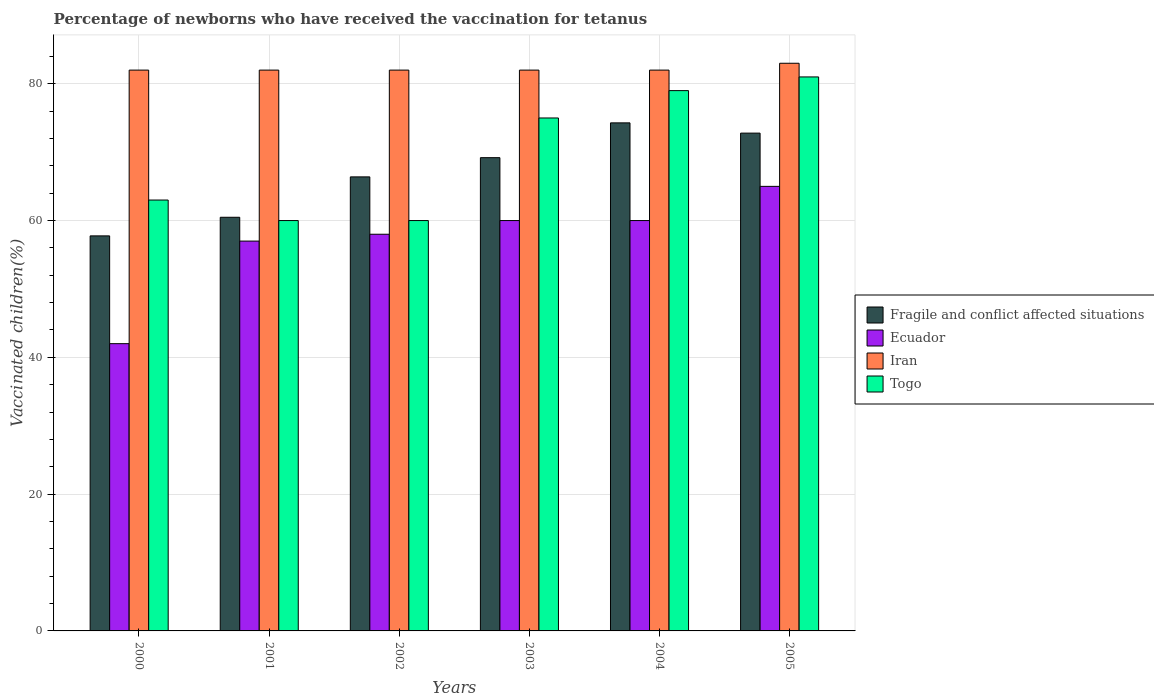How many groups of bars are there?
Provide a succinct answer. 6. Are the number of bars on each tick of the X-axis equal?
Your answer should be compact. Yes. How many bars are there on the 2nd tick from the right?
Ensure brevity in your answer.  4. In how many cases, is the number of bars for a given year not equal to the number of legend labels?
Offer a very short reply. 0. What is the percentage of vaccinated children in Fragile and conflict affected situations in 2004?
Make the answer very short. 74.28. Across all years, what is the maximum percentage of vaccinated children in Ecuador?
Ensure brevity in your answer.  65. In which year was the percentage of vaccinated children in Fragile and conflict affected situations maximum?
Ensure brevity in your answer.  2004. In which year was the percentage of vaccinated children in Iran minimum?
Your response must be concise. 2000. What is the total percentage of vaccinated children in Ecuador in the graph?
Offer a terse response. 342. What is the difference between the percentage of vaccinated children in Fragile and conflict affected situations in 2001 and that in 2005?
Your response must be concise. -12.3. What is the difference between the percentage of vaccinated children in Ecuador in 2000 and the percentage of vaccinated children in Iran in 2001?
Ensure brevity in your answer.  -40. What is the average percentage of vaccinated children in Iran per year?
Provide a short and direct response. 82.17. In the year 2001, what is the difference between the percentage of vaccinated children in Fragile and conflict affected situations and percentage of vaccinated children in Ecuador?
Provide a succinct answer. 3.48. What is the ratio of the percentage of vaccinated children in Fragile and conflict affected situations in 2002 to that in 2004?
Provide a short and direct response. 0.89. Is the percentage of vaccinated children in Iran in 2001 less than that in 2003?
Ensure brevity in your answer.  No. What is the difference between the highest and the second highest percentage of vaccinated children in Ecuador?
Your response must be concise. 5. What is the difference between the highest and the lowest percentage of vaccinated children in Togo?
Provide a succinct answer. 21. In how many years, is the percentage of vaccinated children in Togo greater than the average percentage of vaccinated children in Togo taken over all years?
Provide a succinct answer. 3. What does the 3rd bar from the left in 2003 represents?
Offer a terse response. Iran. What does the 2nd bar from the right in 2005 represents?
Offer a terse response. Iran. How many years are there in the graph?
Your response must be concise. 6. What is the difference between two consecutive major ticks on the Y-axis?
Make the answer very short. 20. How many legend labels are there?
Provide a succinct answer. 4. How are the legend labels stacked?
Ensure brevity in your answer.  Vertical. What is the title of the graph?
Ensure brevity in your answer.  Percentage of newborns who have received the vaccination for tetanus. Does "Australia" appear as one of the legend labels in the graph?
Your answer should be very brief. No. What is the label or title of the X-axis?
Your response must be concise. Years. What is the label or title of the Y-axis?
Make the answer very short. Vaccinated children(%). What is the Vaccinated children(%) of Fragile and conflict affected situations in 2000?
Provide a succinct answer. 57.76. What is the Vaccinated children(%) of Ecuador in 2000?
Make the answer very short. 42. What is the Vaccinated children(%) of Togo in 2000?
Offer a terse response. 63. What is the Vaccinated children(%) of Fragile and conflict affected situations in 2001?
Ensure brevity in your answer.  60.48. What is the Vaccinated children(%) of Iran in 2001?
Your answer should be very brief. 82. What is the Vaccinated children(%) of Fragile and conflict affected situations in 2002?
Keep it short and to the point. 66.39. What is the Vaccinated children(%) in Ecuador in 2002?
Keep it short and to the point. 58. What is the Vaccinated children(%) in Iran in 2002?
Offer a very short reply. 82. What is the Vaccinated children(%) of Fragile and conflict affected situations in 2003?
Your answer should be very brief. 69.2. What is the Vaccinated children(%) in Fragile and conflict affected situations in 2004?
Keep it short and to the point. 74.28. What is the Vaccinated children(%) in Togo in 2004?
Give a very brief answer. 79. What is the Vaccinated children(%) of Fragile and conflict affected situations in 2005?
Keep it short and to the point. 72.78. What is the Vaccinated children(%) in Togo in 2005?
Keep it short and to the point. 81. Across all years, what is the maximum Vaccinated children(%) of Fragile and conflict affected situations?
Provide a short and direct response. 74.28. Across all years, what is the maximum Vaccinated children(%) in Iran?
Your response must be concise. 83. Across all years, what is the maximum Vaccinated children(%) of Togo?
Provide a succinct answer. 81. Across all years, what is the minimum Vaccinated children(%) of Fragile and conflict affected situations?
Your response must be concise. 57.76. Across all years, what is the minimum Vaccinated children(%) in Ecuador?
Provide a short and direct response. 42. Across all years, what is the minimum Vaccinated children(%) of Iran?
Your answer should be very brief. 82. What is the total Vaccinated children(%) in Fragile and conflict affected situations in the graph?
Offer a very short reply. 400.9. What is the total Vaccinated children(%) of Ecuador in the graph?
Keep it short and to the point. 342. What is the total Vaccinated children(%) in Iran in the graph?
Your response must be concise. 493. What is the total Vaccinated children(%) in Togo in the graph?
Your answer should be very brief. 418. What is the difference between the Vaccinated children(%) in Fragile and conflict affected situations in 2000 and that in 2001?
Offer a very short reply. -2.72. What is the difference between the Vaccinated children(%) of Iran in 2000 and that in 2001?
Give a very brief answer. 0. What is the difference between the Vaccinated children(%) in Fragile and conflict affected situations in 2000 and that in 2002?
Ensure brevity in your answer.  -8.63. What is the difference between the Vaccinated children(%) in Ecuador in 2000 and that in 2002?
Your response must be concise. -16. What is the difference between the Vaccinated children(%) in Iran in 2000 and that in 2002?
Your answer should be compact. 0. What is the difference between the Vaccinated children(%) of Togo in 2000 and that in 2002?
Provide a short and direct response. 3. What is the difference between the Vaccinated children(%) in Fragile and conflict affected situations in 2000 and that in 2003?
Offer a terse response. -11.44. What is the difference between the Vaccinated children(%) of Ecuador in 2000 and that in 2003?
Provide a succinct answer. -18. What is the difference between the Vaccinated children(%) of Iran in 2000 and that in 2003?
Offer a very short reply. 0. What is the difference between the Vaccinated children(%) in Fragile and conflict affected situations in 2000 and that in 2004?
Offer a very short reply. -16.52. What is the difference between the Vaccinated children(%) in Ecuador in 2000 and that in 2004?
Offer a very short reply. -18. What is the difference between the Vaccinated children(%) in Fragile and conflict affected situations in 2000 and that in 2005?
Your answer should be compact. -15.02. What is the difference between the Vaccinated children(%) in Iran in 2000 and that in 2005?
Give a very brief answer. -1. What is the difference between the Vaccinated children(%) in Fragile and conflict affected situations in 2001 and that in 2002?
Ensure brevity in your answer.  -5.91. What is the difference between the Vaccinated children(%) of Ecuador in 2001 and that in 2002?
Keep it short and to the point. -1. What is the difference between the Vaccinated children(%) of Iran in 2001 and that in 2002?
Give a very brief answer. 0. What is the difference between the Vaccinated children(%) in Fragile and conflict affected situations in 2001 and that in 2003?
Offer a very short reply. -8.71. What is the difference between the Vaccinated children(%) in Fragile and conflict affected situations in 2001 and that in 2004?
Make the answer very short. -13.8. What is the difference between the Vaccinated children(%) in Iran in 2001 and that in 2004?
Your response must be concise. 0. What is the difference between the Vaccinated children(%) in Fragile and conflict affected situations in 2001 and that in 2005?
Give a very brief answer. -12.3. What is the difference between the Vaccinated children(%) of Ecuador in 2001 and that in 2005?
Give a very brief answer. -8. What is the difference between the Vaccinated children(%) of Iran in 2001 and that in 2005?
Your answer should be compact. -1. What is the difference between the Vaccinated children(%) of Fragile and conflict affected situations in 2002 and that in 2003?
Your response must be concise. -2.81. What is the difference between the Vaccinated children(%) in Ecuador in 2002 and that in 2003?
Offer a terse response. -2. What is the difference between the Vaccinated children(%) in Iran in 2002 and that in 2003?
Keep it short and to the point. 0. What is the difference between the Vaccinated children(%) of Fragile and conflict affected situations in 2002 and that in 2004?
Your answer should be compact. -7.9. What is the difference between the Vaccinated children(%) of Ecuador in 2002 and that in 2004?
Your answer should be compact. -2. What is the difference between the Vaccinated children(%) of Fragile and conflict affected situations in 2002 and that in 2005?
Your response must be concise. -6.4. What is the difference between the Vaccinated children(%) of Ecuador in 2002 and that in 2005?
Ensure brevity in your answer.  -7. What is the difference between the Vaccinated children(%) of Iran in 2002 and that in 2005?
Your response must be concise. -1. What is the difference between the Vaccinated children(%) in Togo in 2002 and that in 2005?
Provide a succinct answer. -21. What is the difference between the Vaccinated children(%) of Fragile and conflict affected situations in 2003 and that in 2004?
Offer a very short reply. -5.09. What is the difference between the Vaccinated children(%) of Iran in 2003 and that in 2004?
Your answer should be very brief. 0. What is the difference between the Vaccinated children(%) in Fragile and conflict affected situations in 2003 and that in 2005?
Make the answer very short. -3.59. What is the difference between the Vaccinated children(%) of Ecuador in 2003 and that in 2005?
Your answer should be very brief. -5. What is the difference between the Vaccinated children(%) of Iran in 2003 and that in 2005?
Your response must be concise. -1. What is the difference between the Vaccinated children(%) of Fragile and conflict affected situations in 2004 and that in 2005?
Your response must be concise. 1.5. What is the difference between the Vaccinated children(%) in Ecuador in 2004 and that in 2005?
Keep it short and to the point. -5. What is the difference between the Vaccinated children(%) in Fragile and conflict affected situations in 2000 and the Vaccinated children(%) in Ecuador in 2001?
Ensure brevity in your answer.  0.76. What is the difference between the Vaccinated children(%) in Fragile and conflict affected situations in 2000 and the Vaccinated children(%) in Iran in 2001?
Offer a terse response. -24.24. What is the difference between the Vaccinated children(%) of Fragile and conflict affected situations in 2000 and the Vaccinated children(%) of Togo in 2001?
Your response must be concise. -2.24. What is the difference between the Vaccinated children(%) in Ecuador in 2000 and the Vaccinated children(%) in Iran in 2001?
Give a very brief answer. -40. What is the difference between the Vaccinated children(%) of Ecuador in 2000 and the Vaccinated children(%) of Togo in 2001?
Offer a terse response. -18. What is the difference between the Vaccinated children(%) in Fragile and conflict affected situations in 2000 and the Vaccinated children(%) in Ecuador in 2002?
Provide a succinct answer. -0.24. What is the difference between the Vaccinated children(%) in Fragile and conflict affected situations in 2000 and the Vaccinated children(%) in Iran in 2002?
Ensure brevity in your answer.  -24.24. What is the difference between the Vaccinated children(%) in Fragile and conflict affected situations in 2000 and the Vaccinated children(%) in Togo in 2002?
Make the answer very short. -2.24. What is the difference between the Vaccinated children(%) in Iran in 2000 and the Vaccinated children(%) in Togo in 2002?
Provide a short and direct response. 22. What is the difference between the Vaccinated children(%) of Fragile and conflict affected situations in 2000 and the Vaccinated children(%) of Ecuador in 2003?
Provide a succinct answer. -2.24. What is the difference between the Vaccinated children(%) in Fragile and conflict affected situations in 2000 and the Vaccinated children(%) in Iran in 2003?
Your response must be concise. -24.24. What is the difference between the Vaccinated children(%) in Fragile and conflict affected situations in 2000 and the Vaccinated children(%) in Togo in 2003?
Provide a succinct answer. -17.24. What is the difference between the Vaccinated children(%) of Ecuador in 2000 and the Vaccinated children(%) of Iran in 2003?
Keep it short and to the point. -40. What is the difference between the Vaccinated children(%) in Ecuador in 2000 and the Vaccinated children(%) in Togo in 2003?
Provide a short and direct response. -33. What is the difference between the Vaccinated children(%) of Fragile and conflict affected situations in 2000 and the Vaccinated children(%) of Ecuador in 2004?
Ensure brevity in your answer.  -2.24. What is the difference between the Vaccinated children(%) of Fragile and conflict affected situations in 2000 and the Vaccinated children(%) of Iran in 2004?
Give a very brief answer. -24.24. What is the difference between the Vaccinated children(%) of Fragile and conflict affected situations in 2000 and the Vaccinated children(%) of Togo in 2004?
Make the answer very short. -21.24. What is the difference between the Vaccinated children(%) in Ecuador in 2000 and the Vaccinated children(%) in Togo in 2004?
Provide a short and direct response. -37. What is the difference between the Vaccinated children(%) of Fragile and conflict affected situations in 2000 and the Vaccinated children(%) of Ecuador in 2005?
Ensure brevity in your answer.  -7.24. What is the difference between the Vaccinated children(%) of Fragile and conflict affected situations in 2000 and the Vaccinated children(%) of Iran in 2005?
Give a very brief answer. -25.24. What is the difference between the Vaccinated children(%) of Fragile and conflict affected situations in 2000 and the Vaccinated children(%) of Togo in 2005?
Your response must be concise. -23.24. What is the difference between the Vaccinated children(%) in Ecuador in 2000 and the Vaccinated children(%) in Iran in 2005?
Your answer should be very brief. -41. What is the difference between the Vaccinated children(%) of Ecuador in 2000 and the Vaccinated children(%) of Togo in 2005?
Make the answer very short. -39. What is the difference between the Vaccinated children(%) in Fragile and conflict affected situations in 2001 and the Vaccinated children(%) in Ecuador in 2002?
Give a very brief answer. 2.48. What is the difference between the Vaccinated children(%) of Fragile and conflict affected situations in 2001 and the Vaccinated children(%) of Iran in 2002?
Provide a short and direct response. -21.52. What is the difference between the Vaccinated children(%) of Fragile and conflict affected situations in 2001 and the Vaccinated children(%) of Togo in 2002?
Make the answer very short. 0.48. What is the difference between the Vaccinated children(%) in Fragile and conflict affected situations in 2001 and the Vaccinated children(%) in Ecuador in 2003?
Keep it short and to the point. 0.48. What is the difference between the Vaccinated children(%) of Fragile and conflict affected situations in 2001 and the Vaccinated children(%) of Iran in 2003?
Provide a short and direct response. -21.52. What is the difference between the Vaccinated children(%) in Fragile and conflict affected situations in 2001 and the Vaccinated children(%) in Togo in 2003?
Offer a very short reply. -14.52. What is the difference between the Vaccinated children(%) of Ecuador in 2001 and the Vaccinated children(%) of Iran in 2003?
Make the answer very short. -25. What is the difference between the Vaccinated children(%) in Ecuador in 2001 and the Vaccinated children(%) in Togo in 2003?
Make the answer very short. -18. What is the difference between the Vaccinated children(%) of Fragile and conflict affected situations in 2001 and the Vaccinated children(%) of Ecuador in 2004?
Keep it short and to the point. 0.48. What is the difference between the Vaccinated children(%) of Fragile and conflict affected situations in 2001 and the Vaccinated children(%) of Iran in 2004?
Your answer should be compact. -21.52. What is the difference between the Vaccinated children(%) in Fragile and conflict affected situations in 2001 and the Vaccinated children(%) in Togo in 2004?
Give a very brief answer. -18.52. What is the difference between the Vaccinated children(%) of Ecuador in 2001 and the Vaccinated children(%) of Iran in 2004?
Offer a very short reply. -25. What is the difference between the Vaccinated children(%) in Fragile and conflict affected situations in 2001 and the Vaccinated children(%) in Ecuador in 2005?
Offer a very short reply. -4.52. What is the difference between the Vaccinated children(%) in Fragile and conflict affected situations in 2001 and the Vaccinated children(%) in Iran in 2005?
Provide a short and direct response. -22.52. What is the difference between the Vaccinated children(%) of Fragile and conflict affected situations in 2001 and the Vaccinated children(%) of Togo in 2005?
Make the answer very short. -20.52. What is the difference between the Vaccinated children(%) of Ecuador in 2001 and the Vaccinated children(%) of Togo in 2005?
Make the answer very short. -24. What is the difference between the Vaccinated children(%) in Fragile and conflict affected situations in 2002 and the Vaccinated children(%) in Ecuador in 2003?
Offer a very short reply. 6.39. What is the difference between the Vaccinated children(%) of Fragile and conflict affected situations in 2002 and the Vaccinated children(%) of Iran in 2003?
Your answer should be very brief. -15.61. What is the difference between the Vaccinated children(%) of Fragile and conflict affected situations in 2002 and the Vaccinated children(%) of Togo in 2003?
Your answer should be very brief. -8.61. What is the difference between the Vaccinated children(%) in Iran in 2002 and the Vaccinated children(%) in Togo in 2003?
Your answer should be compact. 7. What is the difference between the Vaccinated children(%) in Fragile and conflict affected situations in 2002 and the Vaccinated children(%) in Ecuador in 2004?
Make the answer very short. 6.39. What is the difference between the Vaccinated children(%) in Fragile and conflict affected situations in 2002 and the Vaccinated children(%) in Iran in 2004?
Make the answer very short. -15.61. What is the difference between the Vaccinated children(%) of Fragile and conflict affected situations in 2002 and the Vaccinated children(%) of Togo in 2004?
Ensure brevity in your answer.  -12.61. What is the difference between the Vaccinated children(%) of Ecuador in 2002 and the Vaccinated children(%) of Togo in 2004?
Make the answer very short. -21. What is the difference between the Vaccinated children(%) of Iran in 2002 and the Vaccinated children(%) of Togo in 2004?
Your answer should be very brief. 3. What is the difference between the Vaccinated children(%) in Fragile and conflict affected situations in 2002 and the Vaccinated children(%) in Ecuador in 2005?
Give a very brief answer. 1.39. What is the difference between the Vaccinated children(%) of Fragile and conflict affected situations in 2002 and the Vaccinated children(%) of Iran in 2005?
Offer a terse response. -16.61. What is the difference between the Vaccinated children(%) in Fragile and conflict affected situations in 2002 and the Vaccinated children(%) in Togo in 2005?
Make the answer very short. -14.61. What is the difference between the Vaccinated children(%) of Ecuador in 2002 and the Vaccinated children(%) of Iran in 2005?
Make the answer very short. -25. What is the difference between the Vaccinated children(%) in Ecuador in 2002 and the Vaccinated children(%) in Togo in 2005?
Keep it short and to the point. -23. What is the difference between the Vaccinated children(%) in Iran in 2002 and the Vaccinated children(%) in Togo in 2005?
Make the answer very short. 1. What is the difference between the Vaccinated children(%) in Fragile and conflict affected situations in 2003 and the Vaccinated children(%) in Ecuador in 2004?
Your answer should be compact. 9.2. What is the difference between the Vaccinated children(%) in Fragile and conflict affected situations in 2003 and the Vaccinated children(%) in Iran in 2004?
Give a very brief answer. -12.8. What is the difference between the Vaccinated children(%) in Fragile and conflict affected situations in 2003 and the Vaccinated children(%) in Togo in 2004?
Your answer should be very brief. -9.8. What is the difference between the Vaccinated children(%) in Ecuador in 2003 and the Vaccinated children(%) in Iran in 2004?
Provide a short and direct response. -22. What is the difference between the Vaccinated children(%) in Ecuador in 2003 and the Vaccinated children(%) in Togo in 2004?
Ensure brevity in your answer.  -19. What is the difference between the Vaccinated children(%) in Fragile and conflict affected situations in 2003 and the Vaccinated children(%) in Ecuador in 2005?
Your answer should be very brief. 4.2. What is the difference between the Vaccinated children(%) in Fragile and conflict affected situations in 2003 and the Vaccinated children(%) in Iran in 2005?
Your response must be concise. -13.8. What is the difference between the Vaccinated children(%) in Fragile and conflict affected situations in 2003 and the Vaccinated children(%) in Togo in 2005?
Make the answer very short. -11.8. What is the difference between the Vaccinated children(%) of Iran in 2003 and the Vaccinated children(%) of Togo in 2005?
Your response must be concise. 1. What is the difference between the Vaccinated children(%) in Fragile and conflict affected situations in 2004 and the Vaccinated children(%) in Ecuador in 2005?
Provide a succinct answer. 9.28. What is the difference between the Vaccinated children(%) in Fragile and conflict affected situations in 2004 and the Vaccinated children(%) in Iran in 2005?
Provide a succinct answer. -8.72. What is the difference between the Vaccinated children(%) in Fragile and conflict affected situations in 2004 and the Vaccinated children(%) in Togo in 2005?
Offer a terse response. -6.72. What is the difference between the Vaccinated children(%) in Iran in 2004 and the Vaccinated children(%) in Togo in 2005?
Offer a terse response. 1. What is the average Vaccinated children(%) in Fragile and conflict affected situations per year?
Your answer should be compact. 66.82. What is the average Vaccinated children(%) of Iran per year?
Offer a very short reply. 82.17. What is the average Vaccinated children(%) in Togo per year?
Provide a succinct answer. 69.67. In the year 2000, what is the difference between the Vaccinated children(%) of Fragile and conflict affected situations and Vaccinated children(%) of Ecuador?
Provide a succinct answer. 15.76. In the year 2000, what is the difference between the Vaccinated children(%) of Fragile and conflict affected situations and Vaccinated children(%) of Iran?
Offer a terse response. -24.24. In the year 2000, what is the difference between the Vaccinated children(%) in Fragile and conflict affected situations and Vaccinated children(%) in Togo?
Keep it short and to the point. -5.24. In the year 2000, what is the difference between the Vaccinated children(%) in Ecuador and Vaccinated children(%) in Iran?
Offer a terse response. -40. In the year 2000, what is the difference between the Vaccinated children(%) of Ecuador and Vaccinated children(%) of Togo?
Ensure brevity in your answer.  -21. In the year 2001, what is the difference between the Vaccinated children(%) in Fragile and conflict affected situations and Vaccinated children(%) in Ecuador?
Offer a terse response. 3.48. In the year 2001, what is the difference between the Vaccinated children(%) of Fragile and conflict affected situations and Vaccinated children(%) of Iran?
Ensure brevity in your answer.  -21.52. In the year 2001, what is the difference between the Vaccinated children(%) in Fragile and conflict affected situations and Vaccinated children(%) in Togo?
Your response must be concise. 0.48. In the year 2002, what is the difference between the Vaccinated children(%) of Fragile and conflict affected situations and Vaccinated children(%) of Ecuador?
Your answer should be very brief. 8.39. In the year 2002, what is the difference between the Vaccinated children(%) of Fragile and conflict affected situations and Vaccinated children(%) of Iran?
Ensure brevity in your answer.  -15.61. In the year 2002, what is the difference between the Vaccinated children(%) of Fragile and conflict affected situations and Vaccinated children(%) of Togo?
Your answer should be very brief. 6.39. In the year 2002, what is the difference between the Vaccinated children(%) in Ecuador and Vaccinated children(%) in Togo?
Keep it short and to the point. -2. In the year 2002, what is the difference between the Vaccinated children(%) in Iran and Vaccinated children(%) in Togo?
Your answer should be very brief. 22. In the year 2003, what is the difference between the Vaccinated children(%) in Fragile and conflict affected situations and Vaccinated children(%) in Ecuador?
Offer a very short reply. 9.2. In the year 2003, what is the difference between the Vaccinated children(%) in Fragile and conflict affected situations and Vaccinated children(%) in Iran?
Provide a succinct answer. -12.8. In the year 2003, what is the difference between the Vaccinated children(%) in Fragile and conflict affected situations and Vaccinated children(%) in Togo?
Your answer should be very brief. -5.8. In the year 2003, what is the difference between the Vaccinated children(%) in Ecuador and Vaccinated children(%) in Iran?
Ensure brevity in your answer.  -22. In the year 2003, what is the difference between the Vaccinated children(%) in Iran and Vaccinated children(%) in Togo?
Your response must be concise. 7. In the year 2004, what is the difference between the Vaccinated children(%) of Fragile and conflict affected situations and Vaccinated children(%) of Ecuador?
Your answer should be compact. 14.28. In the year 2004, what is the difference between the Vaccinated children(%) of Fragile and conflict affected situations and Vaccinated children(%) of Iran?
Keep it short and to the point. -7.72. In the year 2004, what is the difference between the Vaccinated children(%) of Fragile and conflict affected situations and Vaccinated children(%) of Togo?
Make the answer very short. -4.72. In the year 2004, what is the difference between the Vaccinated children(%) in Iran and Vaccinated children(%) in Togo?
Ensure brevity in your answer.  3. In the year 2005, what is the difference between the Vaccinated children(%) of Fragile and conflict affected situations and Vaccinated children(%) of Ecuador?
Your answer should be compact. 7.78. In the year 2005, what is the difference between the Vaccinated children(%) of Fragile and conflict affected situations and Vaccinated children(%) of Iran?
Keep it short and to the point. -10.22. In the year 2005, what is the difference between the Vaccinated children(%) of Fragile and conflict affected situations and Vaccinated children(%) of Togo?
Make the answer very short. -8.22. In the year 2005, what is the difference between the Vaccinated children(%) in Ecuador and Vaccinated children(%) in Iran?
Keep it short and to the point. -18. In the year 2005, what is the difference between the Vaccinated children(%) of Ecuador and Vaccinated children(%) of Togo?
Keep it short and to the point. -16. In the year 2005, what is the difference between the Vaccinated children(%) of Iran and Vaccinated children(%) of Togo?
Provide a succinct answer. 2. What is the ratio of the Vaccinated children(%) in Fragile and conflict affected situations in 2000 to that in 2001?
Offer a very short reply. 0.95. What is the ratio of the Vaccinated children(%) in Ecuador in 2000 to that in 2001?
Provide a short and direct response. 0.74. What is the ratio of the Vaccinated children(%) in Fragile and conflict affected situations in 2000 to that in 2002?
Ensure brevity in your answer.  0.87. What is the ratio of the Vaccinated children(%) of Ecuador in 2000 to that in 2002?
Your answer should be compact. 0.72. What is the ratio of the Vaccinated children(%) of Iran in 2000 to that in 2002?
Give a very brief answer. 1. What is the ratio of the Vaccinated children(%) in Togo in 2000 to that in 2002?
Your answer should be compact. 1.05. What is the ratio of the Vaccinated children(%) in Fragile and conflict affected situations in 2000 to that in 2003?
Your answer should be compact. 0.83. What is the ratio of the Vaccinated children(%) in Iran in 2000 to that in 2003?
Your answer should be very brief. 1. What is the ratio of the Vaccinated children(%) in Togo in 2000 to that in 2003?
Offer a terse response. 0.84. What is the ratio of the Vaccinated children(%) in Fragile and conflict affected situations in 2000 to that in 2004?
Give a very brief answer. 0.78. What is the ratio of the Vaccinated children(%) of Ecuador in 2000 to that in 2004?
Offer a terse response. 0.7. What is the ratio of the Vaccinated children(%) in Togo in 2000 to that in 2004?
Your answer should be very brief. 0.8. What is the ratio of the Vaccinated children(%) of Fragile and conflict affected situations in 2000 to that in 2005?
Make the answer very short. 0.79. What is the ratio of the Vaccinated children(%) in Ecuador in 2000 to that in 2005?
Make the answer very short. 0.65. What is the ratio of the Vaccinated children(%) in Togo in 2000 to that in 2005?
Provide a succinct answer. 0.78. What is the ratio of the Vaccinated children(%) in Fragile and conflict affected situations in 2001 to that in 2002?
Give a very brief answer. 0.91. What is the ratio of the Vaccinated children(%) of Ecuador in 2001 to that in 2002?
Offer a terse response. 0.98. What is the ratio of the Vaccinated children(%) in Fragile and conflict affected situations in 2001 to that in 2003?
Your response must be concise. 0.87. What is the ratio of the Vaccinated children(%) of Iran in 2001 to that in 2003?
Provide a short and direct response. 1. What is the ratio of the Vaccinated children(%) of Togo in 2001 to that in 2003?
Provide a succinct answer. 0.8. What is the ratio of the Vaccinated children(%) of Fragile and conflict affected situations in 2001 to that in 2004?
Provide a short and direct response. 0.81. What is the ratio of the Vaccinated children(%) in Togo in 2001 to that in 2004?
Make the answer very short. 0.76. What is the ratio of the Vaccinated children(%) of Fragile and conflict affected situations in 2001 to that in 2005?
Your answer should be very brief. 0.83. What is the ratio of the Vaccinated children(%) in Ecuador in 2001 to that in 2005?
Offer a very short reply. 0.88. What is the ratio of the Vaccinated children(%) of Togo in 2001 to that in 2005?
Offer a terse response. 0.74. What is the ratio of the Vaccinated children(%) of Fragile and conflict affected situations in 2002 to that in 2003?
Provide a short and direct response. 0.96. What is the ratio of the Vaccinated children(%) of Ecuador in 2002 to that in 2003?
Your answer should be compact. 0.97. What is the ratio of the Vaccinated children(%) in Iran in 2002 to that in 2003?
Your answer should be very brief. 1. What is the ratio of the Vaccinated children(%) of Togo in 2002 to that in 2003?
Your answer should be very brief. 0.8. What is the ratio of the Vaccinated children(%) of Fragile and conflict affected situations in 2002 to that in 2004?
Provide a short and direct response. 0.89. What is the ratio of the Vaccinated children(%) of Ecuador in 2002 to that in 2004?
Give a very brief answer. 0.97. What is the ratio of the Vaccinated children(%) of Iran in 2002 to that in 2004?
Offer a terse response. 1. What is the ratio of the Vaccinated children(%) of Togo in 2002 to that in 2004?
Your answer should be very brief. 0.76. What is the ratio of the Vaccinated children(%) of Fragile and conflict affected situations in 2002 to that in 2005?
Offer a terse response. 0.91. What is the ratio of the Vaccinated children(%) of Ecuador in 2002 to that in 2005?
Your response must be concise. 0.89. What is the ratio of the Vaccinated children(%) in Togo in 2002 to that in 2005?
Make the answer very short. 0.74. What is the ratio of the Vaccinated children(%) in Fragile and conflict affected situations in 2003 to that in 2004?
Your answer should be very brief. 0.93. What is the ratio of the Vaccinated children(%) in Togo in 2003 to that in 2004?
Provide a short and direct response. 0.95. What is the ratio of the Vaccinated children(%) of Fragile and conflict affected situations in 2003 to that in 2005?
Your response must be concise. 0.95. What is the ratio of the Vaccinated children(%) in Ecuador in 2003 to that in 2005?
Ensure brevity in your answer.  0.92. What is the ratio of the Vaccinated children(%) of Iran in 2003 to that in 2005?
Provide a short and direct response. 0.99. What is the ratio of the Vaccinated children(%) of Togo in 2003 to that in 2005?
Keep it short and to the point. 0.93. What is the ratio of the Vaccinated children(%) in Fragile and conflict affected situations in 2004 to that in 2005?
Keep it short and to the point. 1.02. What is the ratio of the Vaccinated children(%) in Togo in 2004 to that in 2005?
Offer a terse response. 0.98. What is the difference between the highest and the second highest Vaccinated children(%) of Ecuador?
Your answer should be compact. 5. What is the difference between the highest and the second highest Vaccinated children(%) of Iran?
Give a very brief answer. 1. What is the difference between the highest and the second highest Vaccinated children(%) of Togo?
Provide a short and direct response. 2. What is the difference between the highest and the lowest Vaccinated children(%) in Fragile and conflict affected situations?
Offer a very short reply. 16.52. What is the difference between the highest and the lowest Vaccinated children(%) of Iran?
Ensure brevity in your answer.  1. 